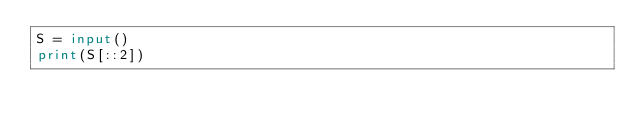<code> <loc_0><loc_0><loc_500><loc_500><_Python_>S = input()
print(S[::2])</code> 